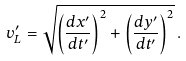<formula> <loc_0><loc_0><loc_500><loc_500>v ^ { \prime } _ { L } = \sqrt { \left ( \frac { d x ^ { \prime } } { d t ^ { \prime } } \right ) ^ { 2 } + \left ( \frac { d y ^ { \prime } } { d t ^ { \prime } } \right ) ^ { 2 } } \, .</formula> 